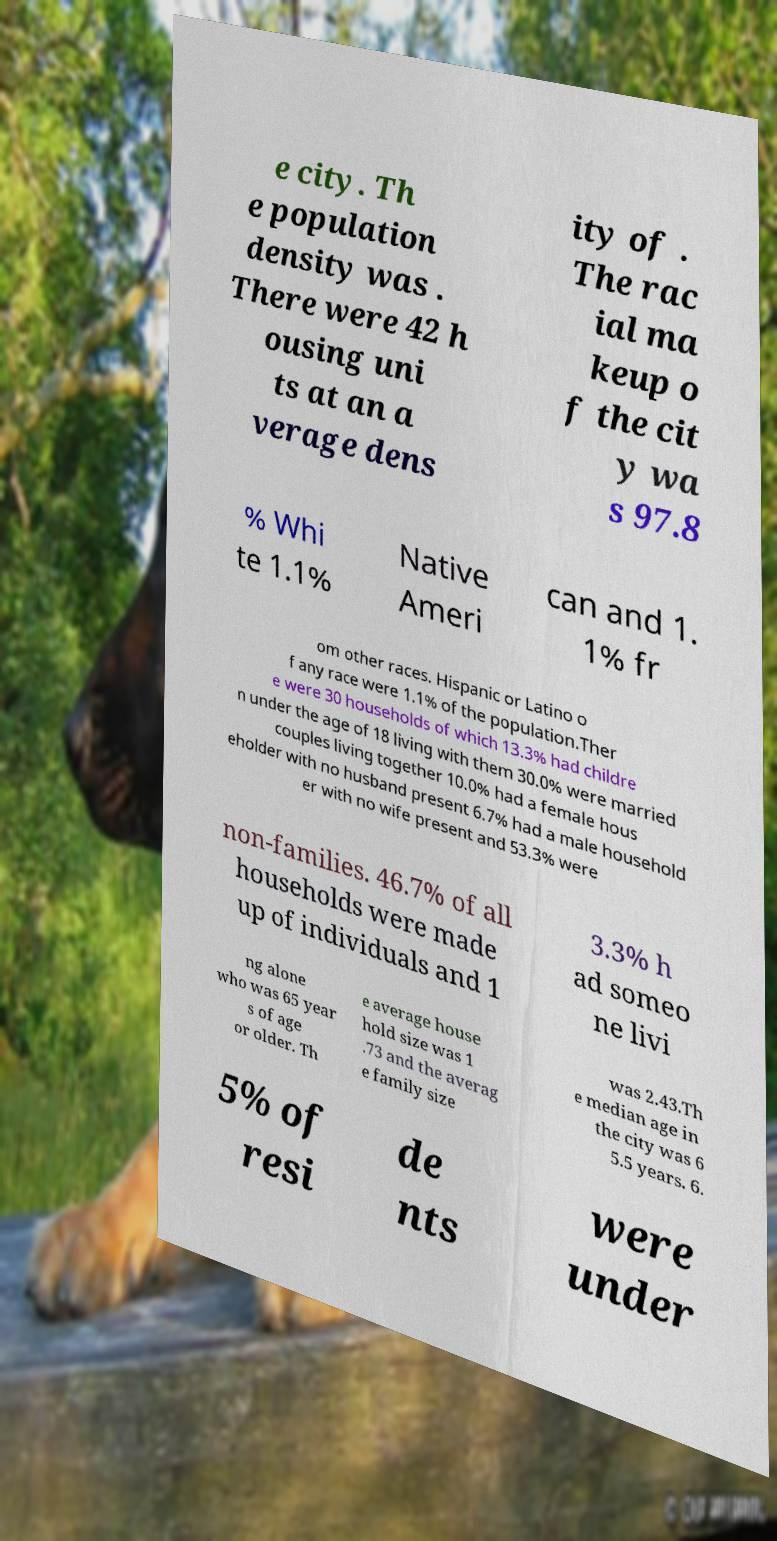There's text embedded in this image that I need extracted. Can you transcribe it verbatim? e city. Th e population density was . There were 42 h ousing uni ts at an a verage dens ity of . The rac ial ma keup o f the cit y wa s 97.8 % Whi te 1.1% Native Ameri can and 1. 1% fr om other races. Hispanic or Latino o f any race were 1.1% of the population.Ther e were 30 households of which 13.3% had childre n under the age of 18 living with them 30.0% were married couples living together 10.0% had a female hous eholder with no husband present 6.7% had a male household er with no wife present and 53.3% were non-families. 46.7% of all households were made up of individuals and 1 3.3% h ad someo ne livi ng alone who was 65 year s of age or older. Th e average house hold size was 1 .73 and the averag e family size was 2.43.Th e median age in the city was 6 5.5 years. 6. 5% of resi de nts were under 